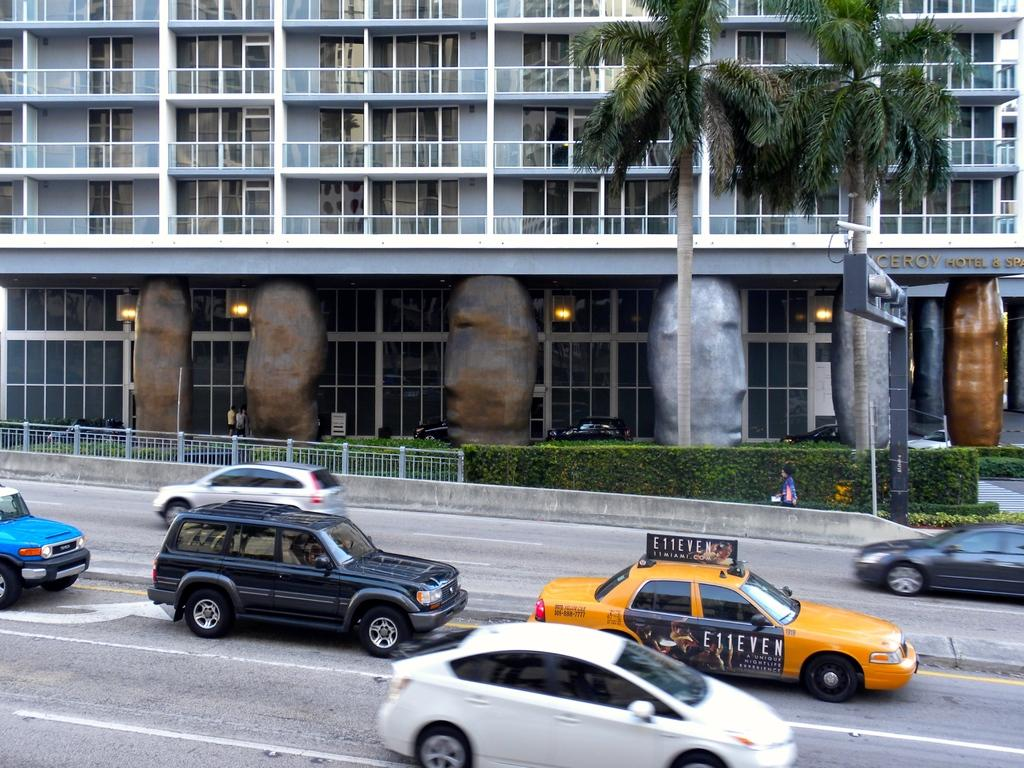<image>
Describe the image concisely. A yellow cab with an advertisement for E11EVEN on top. 